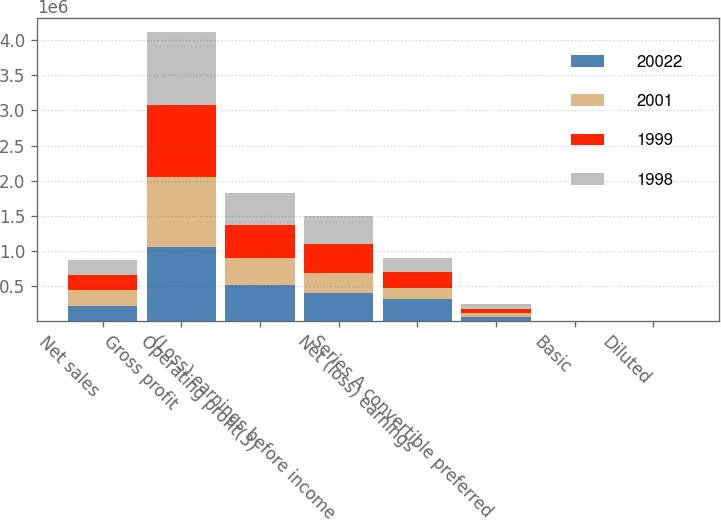Convert chart. <chart><loc_0><loc_0><loc_500><loc_500><stacked_bar_chart><ecel><fcel>Net sales<fcel>Gross profit<fcel>Operating profit(3)<fcel>(Loss) earnings before income<fcel>Net (loss) earnings<fcel>Series A convertible preferred<fcel>Basic<fcel>Diluted<nl><fcel>20022<fcel>218390<fcel>1.05761e+06<fcel>516386<fcel>391933<fcel>309069<fcel>53845<fcel>4.2<fcel>4.3<nl><fcel>2001<fcel>218390<fcel>990287<fcel>387391<fcel>297452<fcel>156697<fcel>55024<fcel>1.3<fcel>1.22<nl><fcel>1999<fcel>218390<fcel>1.0353e+06<fcel>468463<fcel>413429<fcel>225319<fcel>64266<fcel>2.47<fcel>1.93<nl><fcel>1998<fcel>218390<fcel>1.02872e+06<fcel>452192<fcel>395653<fcel>211461<fcel>71422<fcel>1.69<fcel>1.68<nl></chart> 